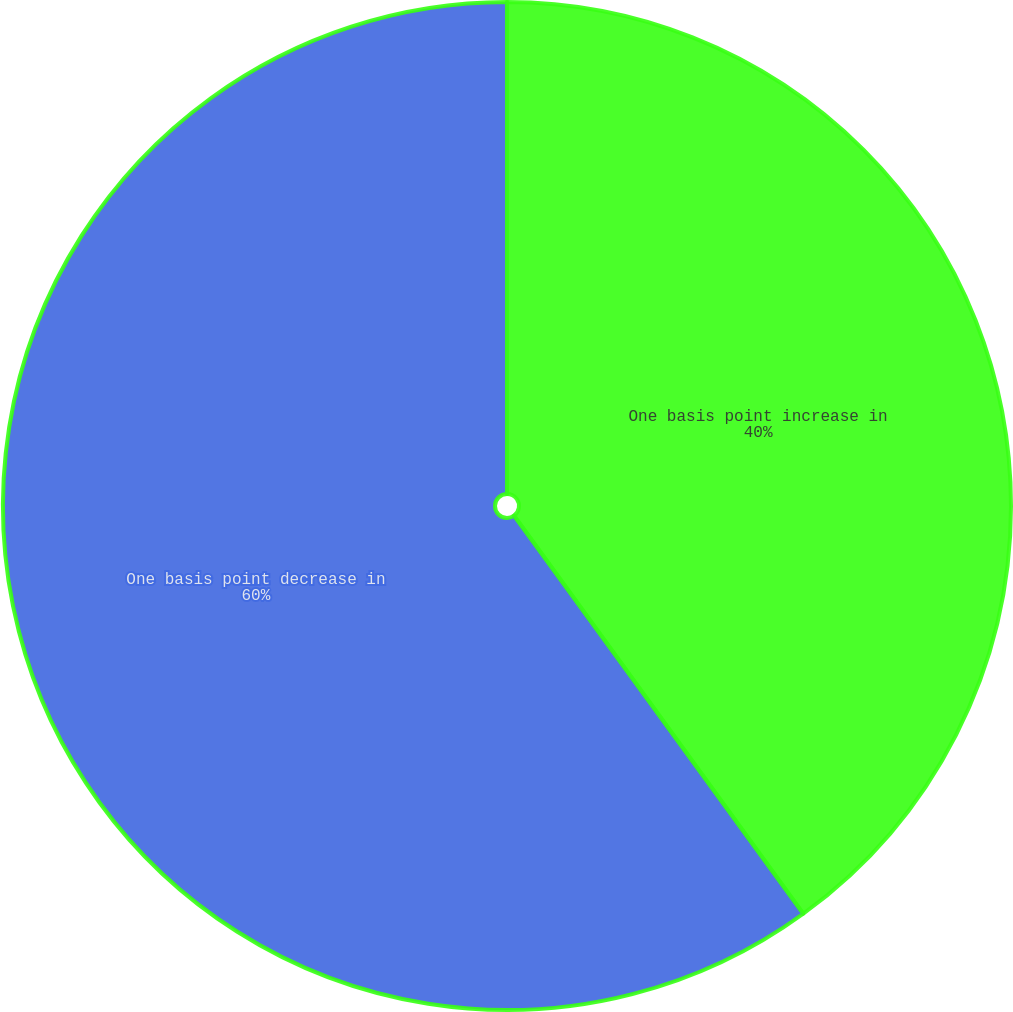<chart> <loc_0><loc_0><loc_500><loc_500><pie_chart><fcel>One basis point increase in<fcel>One basis point decrease in<nl><fcel>40.0%<fcel>60.0%<nl></chart> 